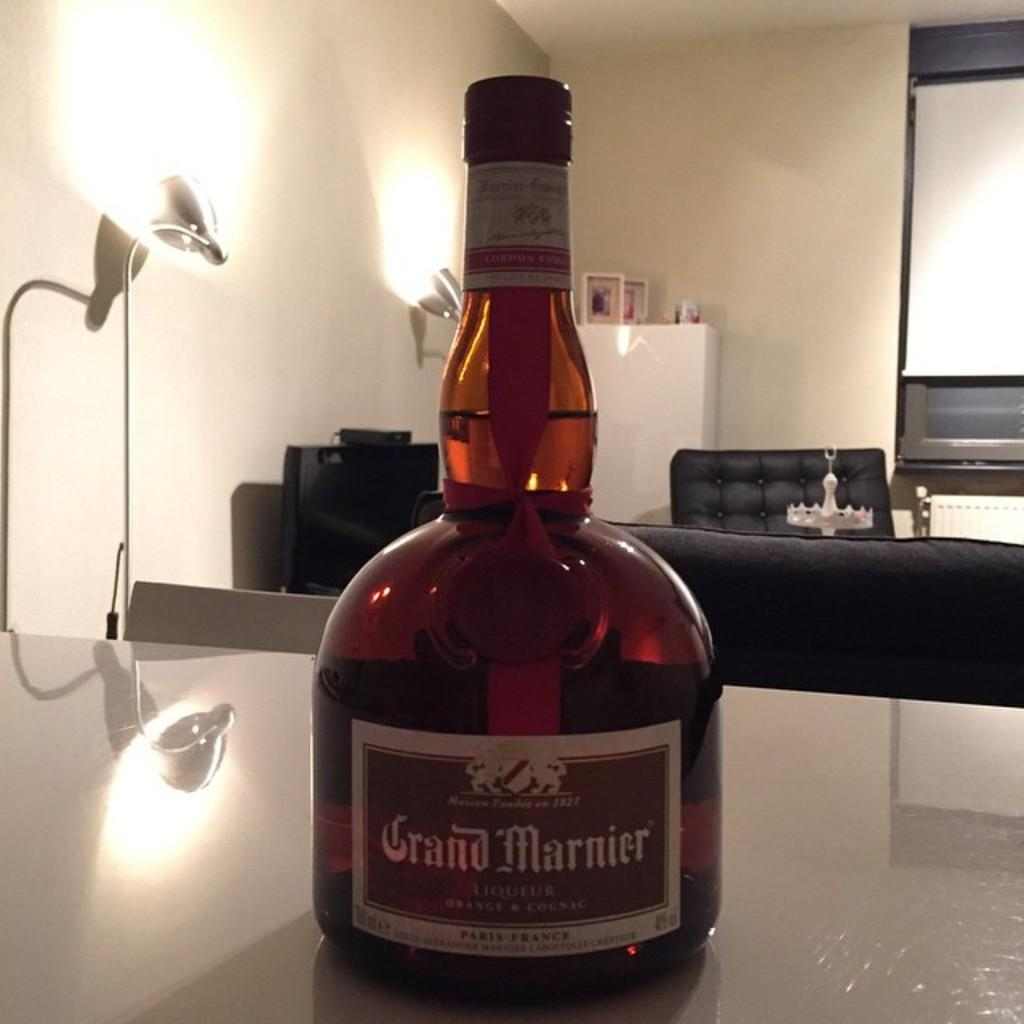<image>
Offer a succinct explanation of the picture presented. the word grand is on a bottle of whiskey 